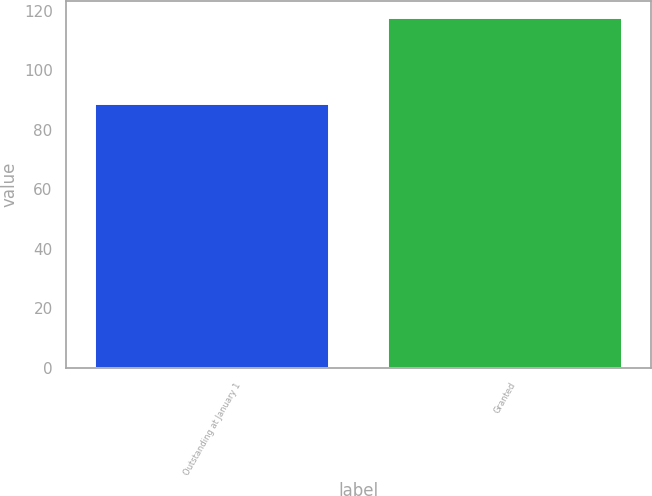Convert chart to OTSL. <chart><loc_0><loc_0><loc_500><loc_500><bar_chart><fcel>Outstanding at January 1<fcel>Granted<nl><fcel>88.57<fcel>117.55<nl></chart> 